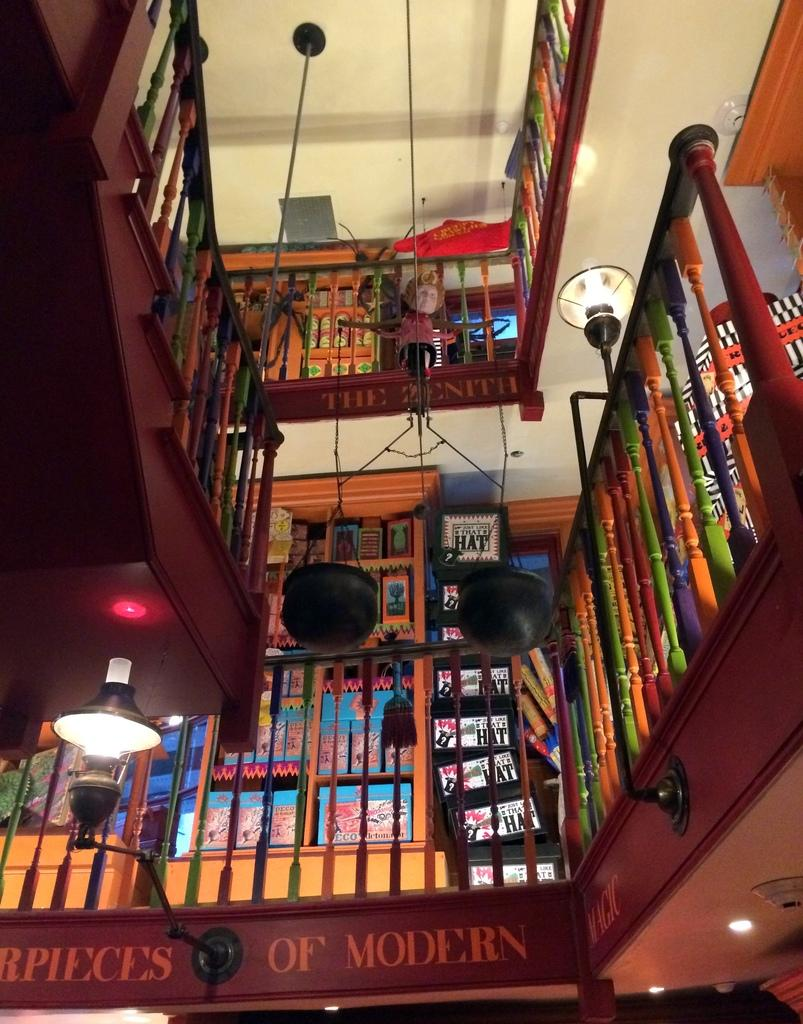<image>
Render a clear and concise summary of the photo. A room says pieces of modern on the wall 